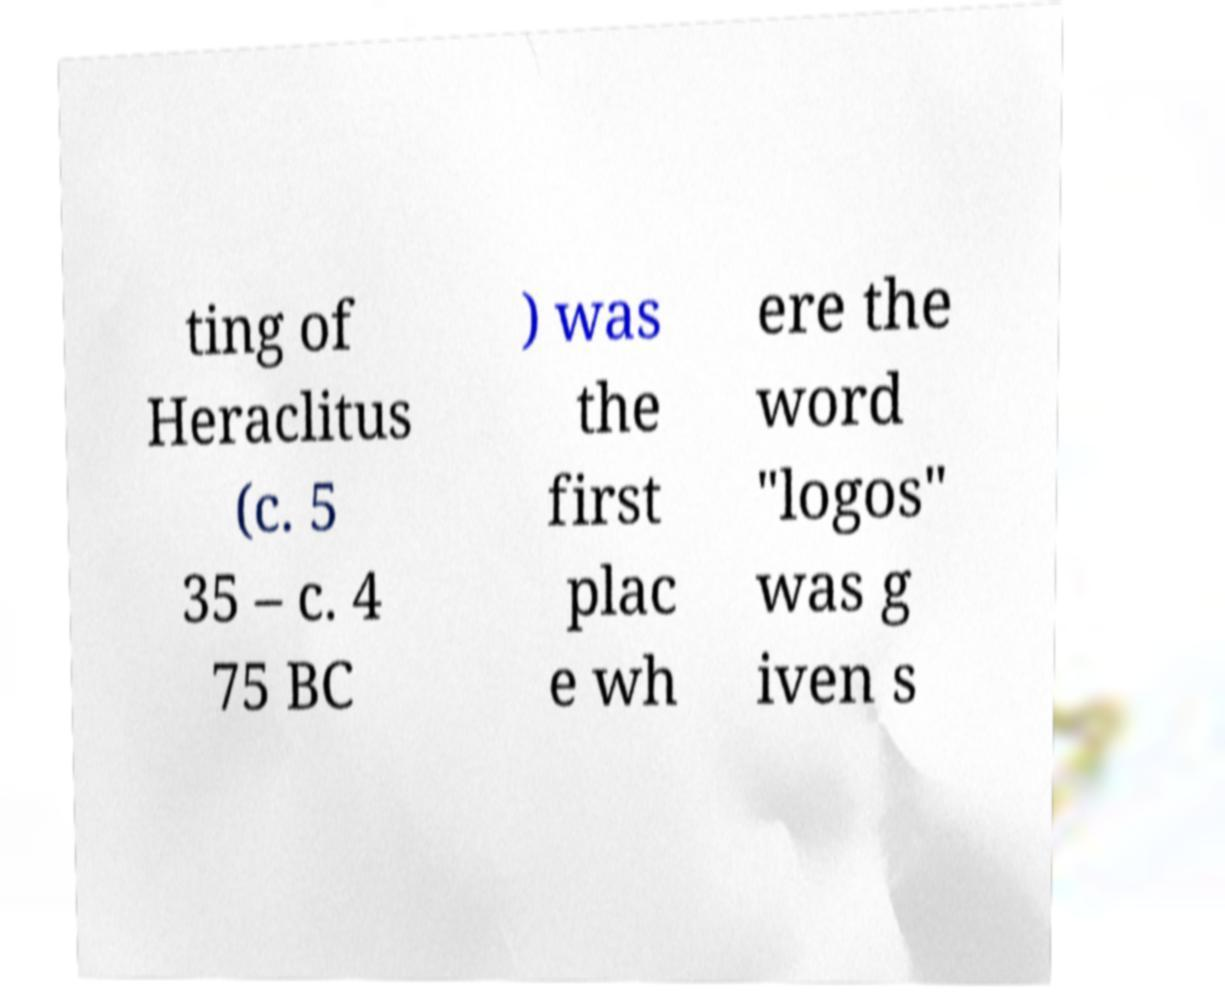Can you read and provide the text displayed in the image?This photo seems to have some interesting text. Can you extract and type it out for me? ting of Heraclitus (c. 5 35 – c. 4 75 BC ) was the first plac e wh ere the word "logos" was g iven s 